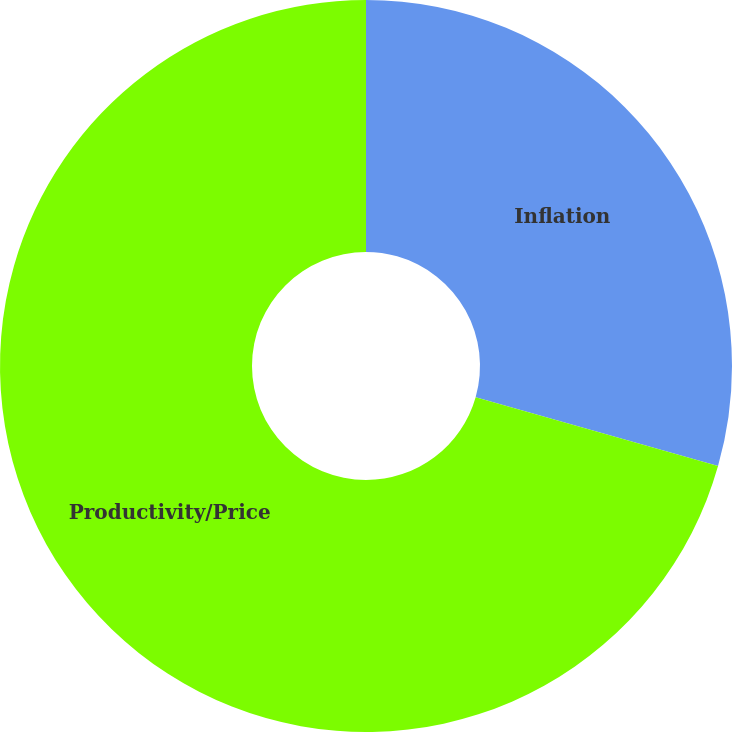<chart> <loc_0><loc_0><loc_500><loc_500><pie_chart><fcel>Inflation<fcel>Productivity/Price<nl><fcel>29.41%<fcel>70.59%<nl></chart> 